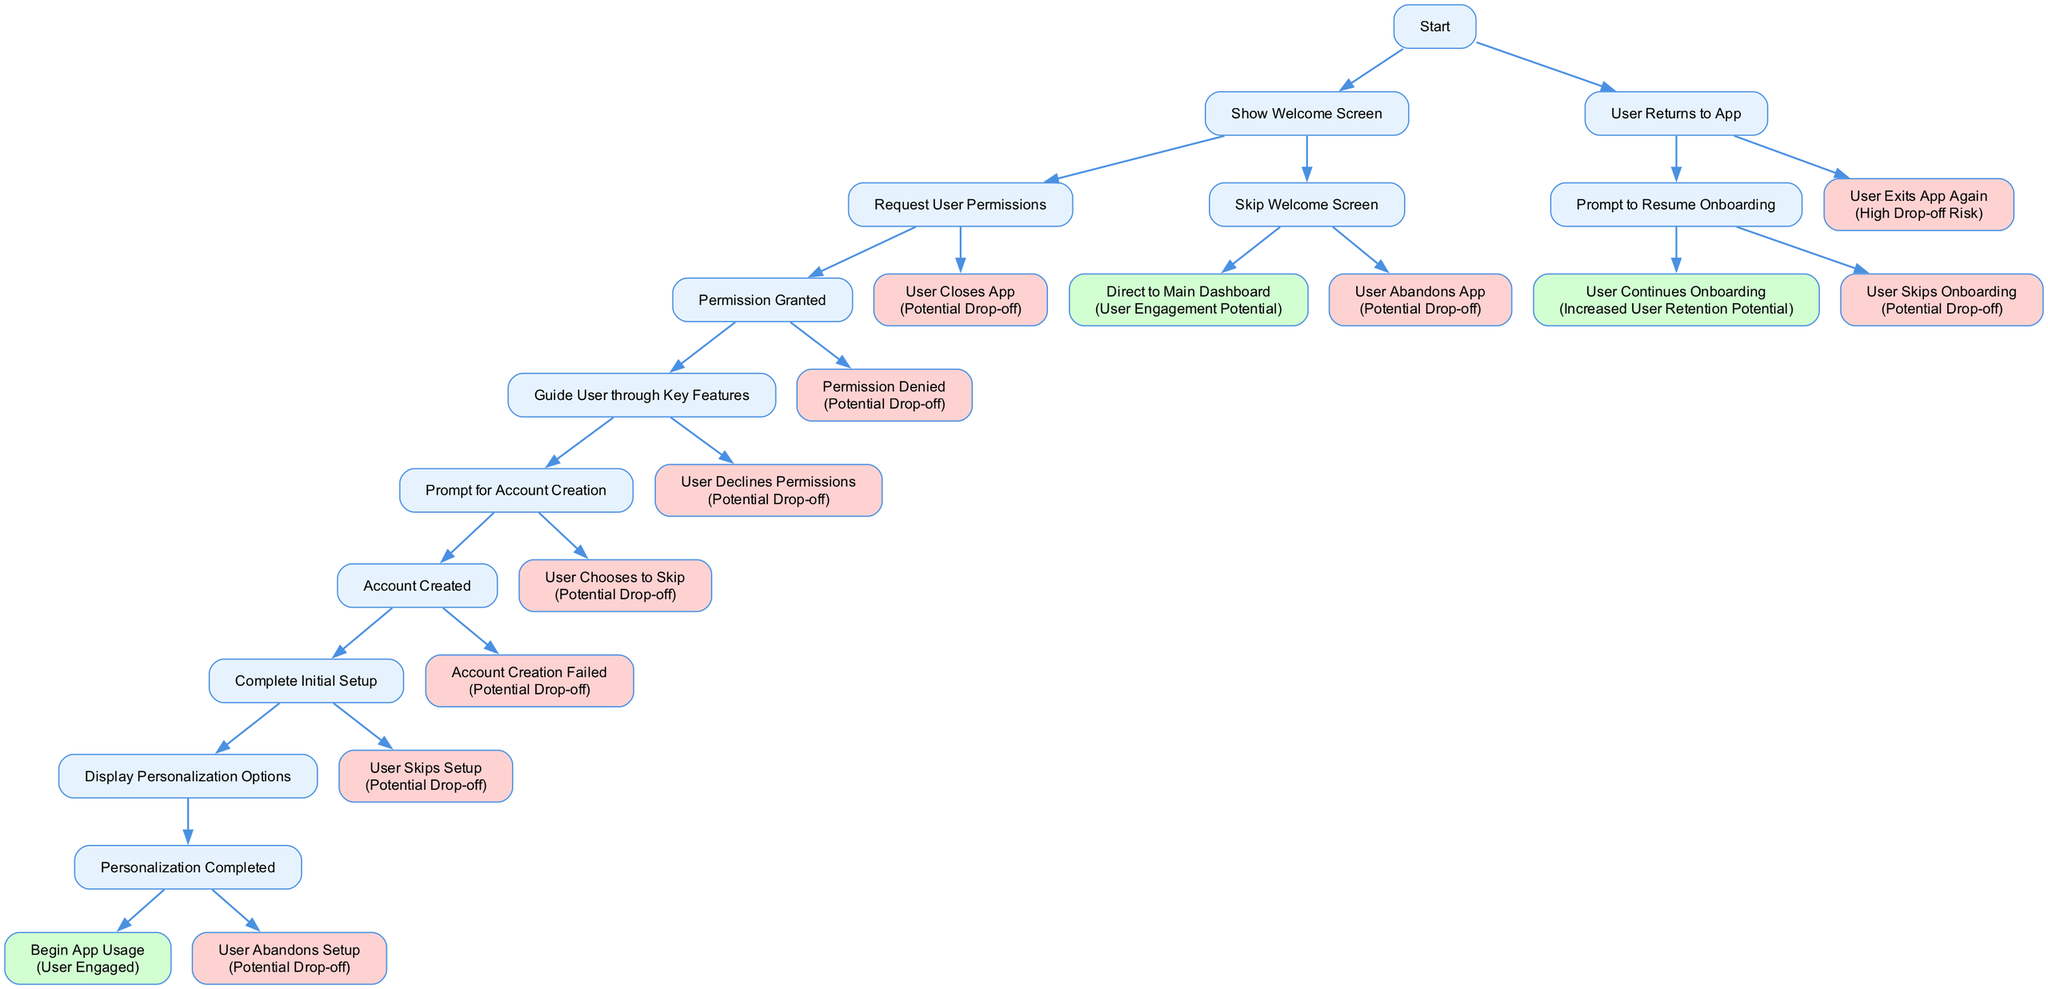what is the first action in the user onboarding flow? The first action is "First Time App Launch," which is the entry point of the onboarding flow. It is the starting node that leads to the subsequent decisions.
Answer: First Time App Launch how many decision points are there in the flow? By reviewing the diagram, the main decision points can be counted, which include choices made by the user at different stages. There are three main decision points where choices diverge.
Answer: 3 what happens if the user skips the welcome screen? If the user skips the welcome screen, they are directly taken to the main dashboard, indicated in the flow. This shows an alternative path that does not engage the user with the initial onboarding steps.
Answer: Direct to Main Dashboard what is the consequence if the user opts to skip account creation? The flow indicates that if the user chooses to skip account creation, the result is marked as a "Potential Drop-off," highlighting a risk of losing user engagement at this stage.
Answer: Potential Drop-off which action leads to the highest likelihood of user engagement? The flow suggests that successful completion of the entire onboarding process, including personalization and beginning app usage, results in "User Engaged," which indicates the highest likelihood of retaining user interest.
Answer: User Engaged if a user declines permissions, what is the outcome? According to the diagram, if a user declines permissions, the outcome is classified as a "Potential Drop-off," indicating that not granting permissions can lead to a loss of user engagement.
Answer: Potential Drop-off what is the last action in the flow for a successfully engaged user? The last action for a successfully engaged user is "Begin App Usage," which culminates the onboarding process and signifies the user's active participation in the app.
Answer: Begin App Usage what is the node that represents the account creation failure? The failure of account creation is represented by the node labeled "Account Creation Failed," which explicitly states the outcome leading to potential drop-off.
Answer: Account Creation Failed how does the user flow change if the user returns to the app after closing it? The flow indicates that if the user returns to the app after closing it, they are prompted to resume onboarding, allowing for a potential continuation of the engagement process rather than starting over.
Answer: Prompt to Resume Onboarding 